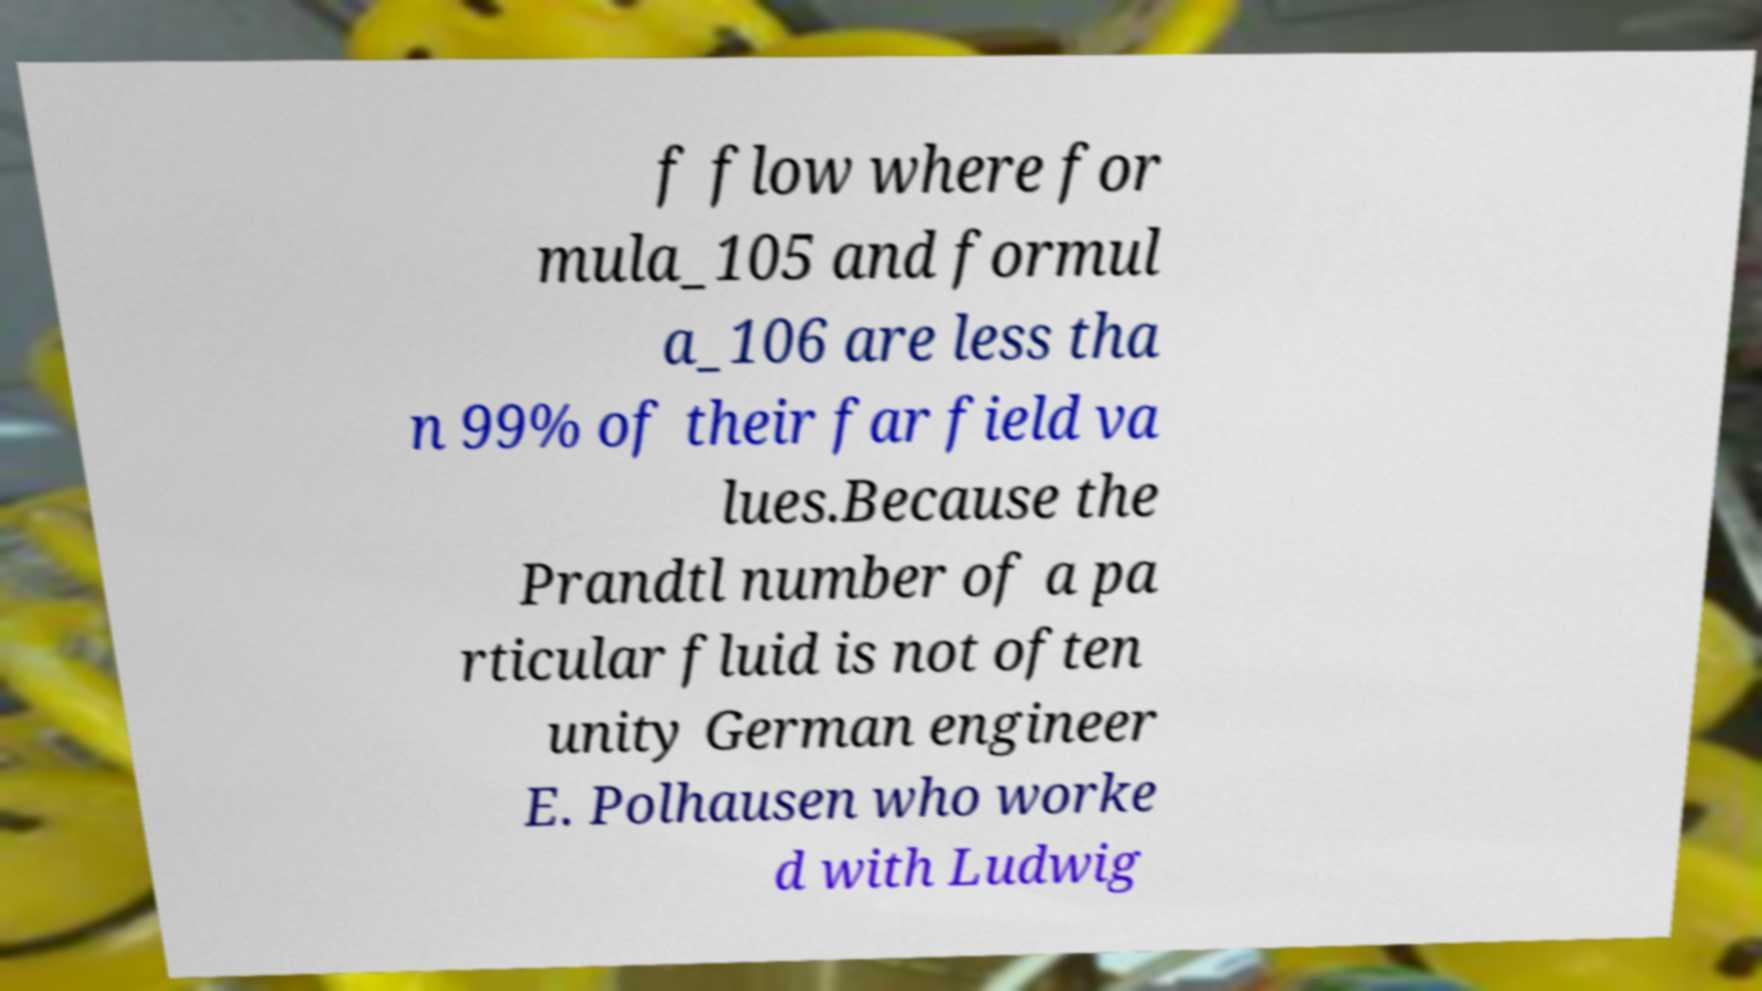Could you extract and type out the text from this image? f flow where for mula_105 and formul a_106 are less tha n 99% of their far field va lues.Because the Prandtl number of a pa rticular fluid is not often unity German engineer E. Polhausen who worke d with Ludwig 